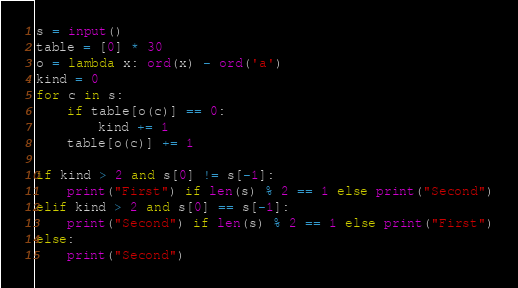Convert code to text. <code><loc_0><loc_0><loc_500><loc_500><_Python_>s = input()
table = [0] * 30
o = lambda x: ord(x) - ord('a')
kind = 0
for c in s:
    if table[o(c)] == 0:
        kind += 1
    table[o(c)] += 1

if kind > 2 and s[0] != s[-1]:
    print("First") if len(s) % 2 == 1 else print("Second")
elif kind > 2 and s[0] == s[-1]:
    print("Second") if len(s) % 2 == 1 else print("First")
else:
    print("Second")
</code> 